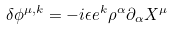<formula> <loc_0><loc_0><loc_500><loc_500>\delta \phi ^ { \mu , k } = - i \epsilon e ^ { k } \rho ^ { \alpha } \partial _ { \alpha } X ^ { \mu }</formula> 